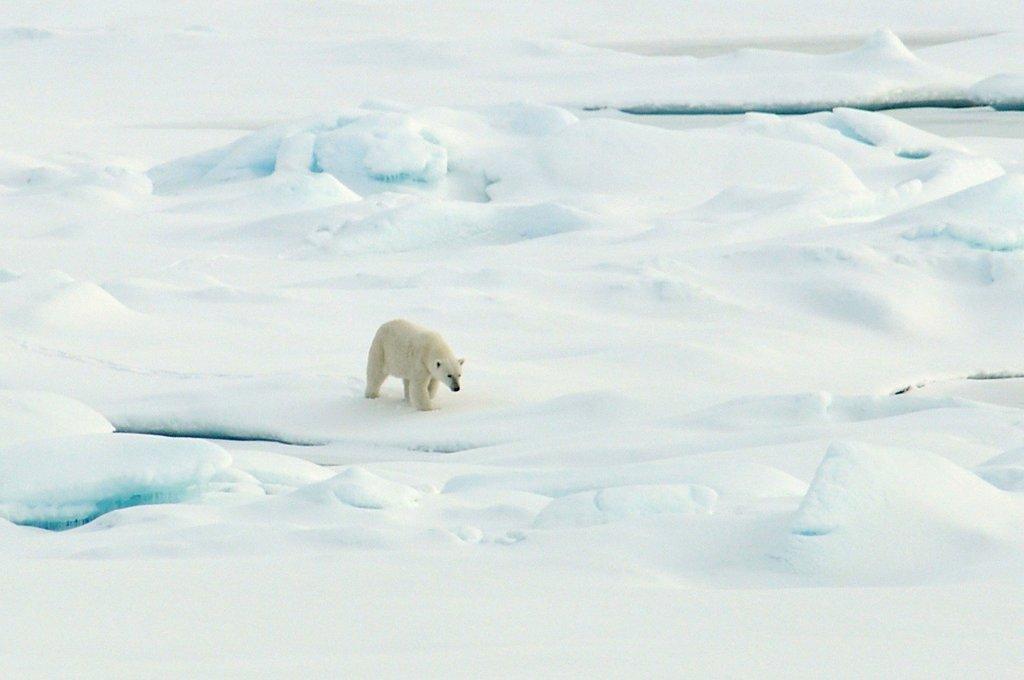How would you summarize this image in a sentence or two? In this image we can see a white polar bear on the ice. 